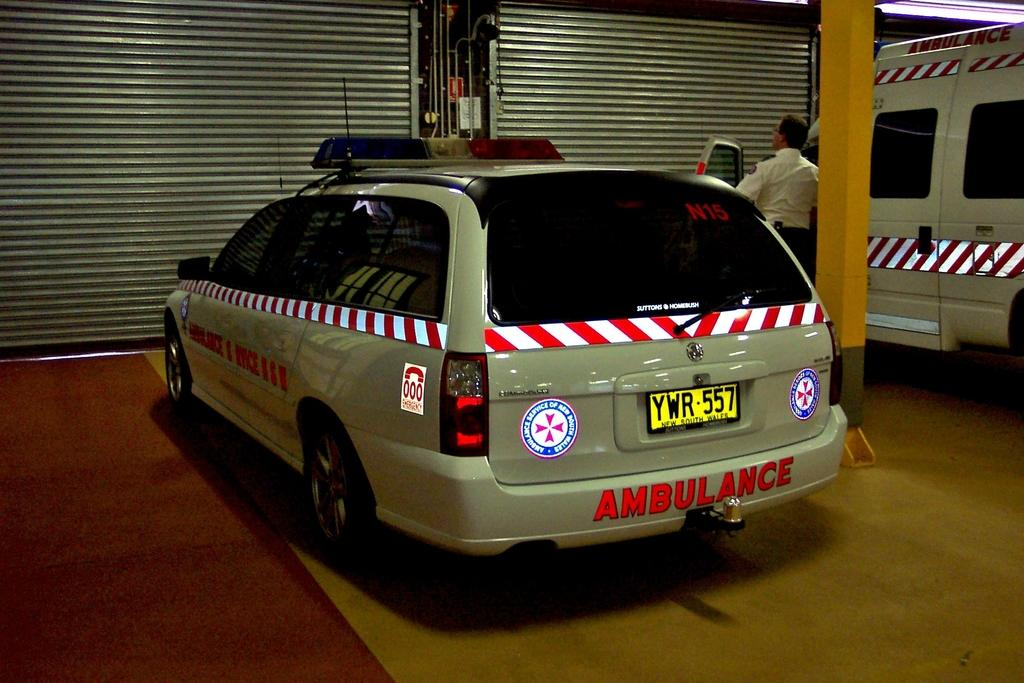What types of objects are present in the image? There are vehicles in the image. What is at the bottom of the image? There is a floor at the bottom of the image. What can be seen in the background of the image? There are shutters, rods, and pillars in the background of the image. Is there anyone present in the image? Yes, a person is standing near a vehicle in the image. What type of drug is being transported in the crate in the image? There is no crate or drug present in the image. What is the source of power for the vehicles in the image? The image does not provide information about the source of power for the vehicles. 